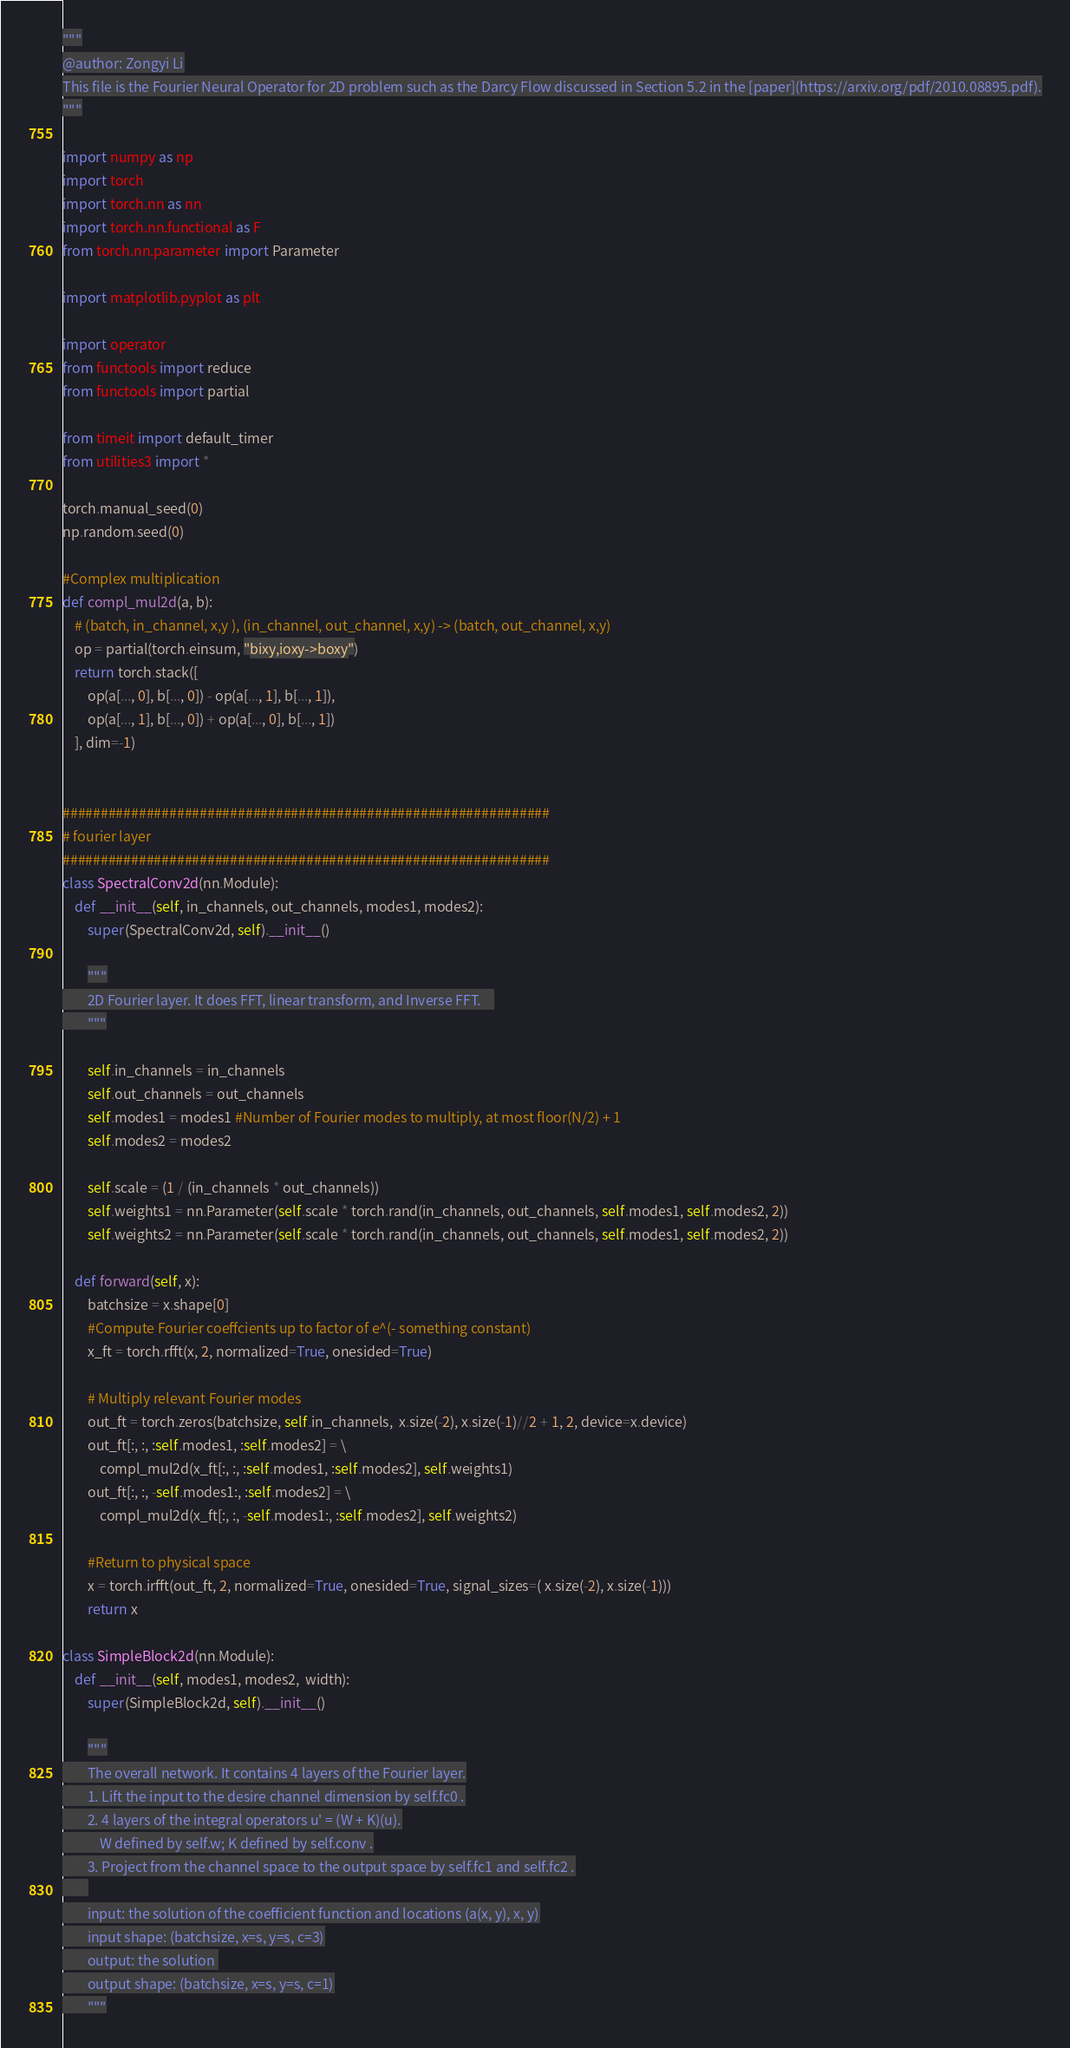Convert code to text. <code><loc_0><loc_0><loc_500><loc_500><_Python_>"""
@author: Zongyi Li
This file is the Fourier Neural Operator for 2D problem such as the Darcy Flow discussed in Section 5.2 in the [paper](https://arxiv.org/pdf/2010.08895.pdf).
"""

import numpy as np
import torch
import torch.nn as nn
import torch.nn.functional as F
from torch.nn.parameter import Parameter

import matplotlib.pyplot as plt

import operator
from functools import reduce
from functools import partial

from timeit import default_timer
from utilities3 import *

torch.manual_seed(0)
np.random.seed(0)

#Complex multiplication
def compl_mul2d(a, b):
    # (batch, in_channel, x,y ), (in_channel, out_channel, x,y) -> (batch, out_channel, x,y)
    op = partial(torch.einsum, "bixy,ioxy->boxy")
    return torch.stack([
        op(a[..., 0], b[..., 0]) - op(a[..., 1], b[..., 1]),
        op(a[..., 1], b[..., 0]) + op(a[..., 0], b[..., 1])
    ], dim=-1)


################################################################
# fourier layer
################################################################
class SpectralConv2d(nn.Module):
    def __init__(self, in_channels, out_channels, modes1, modes2):
        super(SpectralConv2d, self).__init__()

        """
        2D Fourier layer. It does FFT, linear transform, and Inverse FFT.    
        """

        self.in_channels = in_channels
        self.out_channels = out_channels
        self.modes1 = modes1 #Number of Fourier modes to multiply, at most floor(N/2) + 1
        self.modes2 = modes2

        self.scale = (1 / (in_channels * out_channels))
        self.weights1 = nn.Parameter(self.scale * torch.rand(in_channels, out_channels, self.modes1, self.modes2, 2))
        self.weights2 = nn.Parameter(self.scale * torch.rand(in_channels, out_channels, self.modes1, self.modes2, 2))

    def forward(self, x):
        batchsize = x.shape[0]
        #Compute Fourier coeffcients up to factor of e^(- something constant)
        x_ft = torch.rfft(x, 2, normalized=True, onesided=True)

        # Multiply relevant Fourier modes
        out_ft = torch.zeros(batchsize, self.in_channels,  x.size(-2), x.size(-1)//2 + 1, 2, device=x.device)
        out_ft[:, :, :self.modes1, :self.modes2] = \
            compl_mul2d(x_ft[:, :, :self.modes1, :self.modes2], self.weights1)
        out_ft[:, :, -self.modes1:, :self.modes2] = \
            compl_mul2d(x_ft[:, :, -self.modes1:, :self.modes2], self.weights2)

        #Return to physical space
        x = torch.irfft(out_ft, 2, normalized=True, onesided=True, signal_sizes=( x.size(-2), x.size(-1)))
        return x

class SimpleBlock2d(nn.Module):
    def __init__(self, modes1, modes2,  width):
        super(SimpleBlock2d, self).__init__()

        """
        The overall network. It contains 4 layers of the Fourier layer.
        1. Lift the input to the desire channel dimension by self.fc0 .
        2. 4 layers of the integral operators u' = (W + K)(u).
            W defined by self.w; K defined by self.conv .
        3. Project from the channel space to the output space by self.fc1 and self.fc2 .
        
        input: the solution of the coefficient function and locations (a(x, y), x, y)
        input shape: (batchsize, x=s, y=s, c=3)
        output: the solution 
        output shape: (batchsize, x=s, y=s, c=1)
        """
</code> 